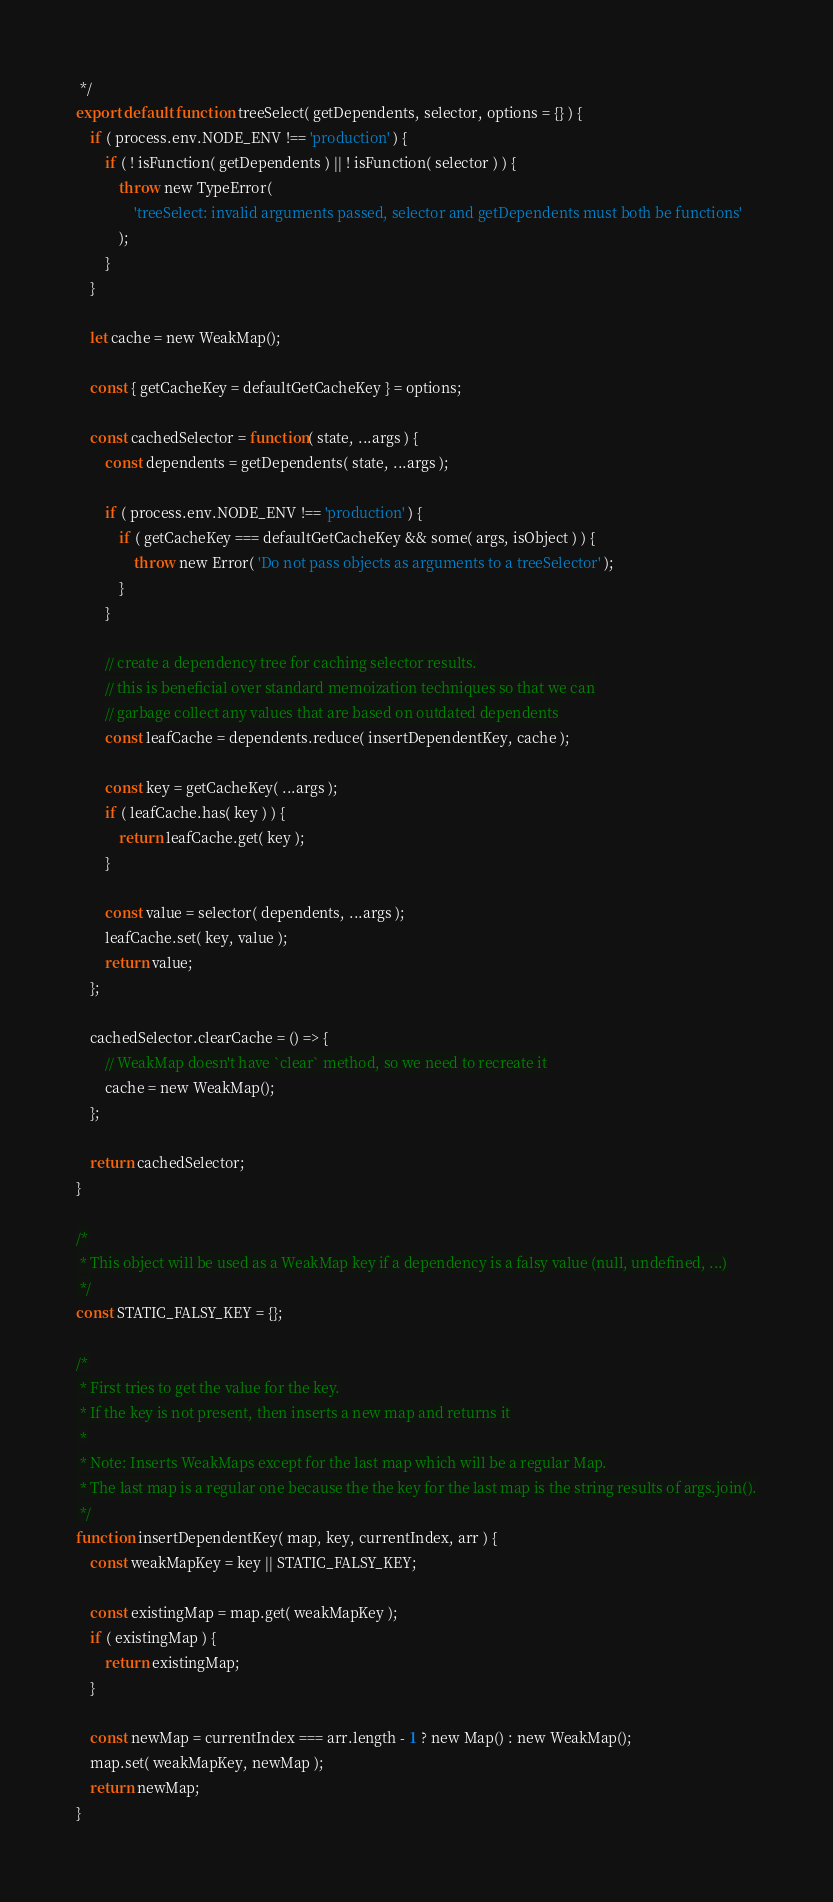<code> <loc_0><loc_0><loc_500><loc_500><_JavaScript_> */
export default function treeSelect( getDependents, selector, options = {} ) {
	if ( process.env.NODE_ENV !== 'production' ) {
		if ( ! isFunction( getDependents ) || ! isFunction( selector ) ) {
			throw new TypeError(
				'treeSelect: invalid arguments passed, selector and getDependents must both be functions'
			);
		}
	}

	let cache = new WeakMap();

	const { getCacheKey = defaultGetCacheKey } = options;

	const cachedSelector = function( state, ...args ) {
		const dependents = getDependents( state, ...args );

		if ( process.env.NODE_ENV !== 'production' ) {
			if ( getCacheKey === defaultGetCacheKey && some( args, isObject ) ) {
				throw new Error( 'Do not pass objects as arguments to a treeSelector' );
			}
		}

		// create a dependency tree for caching selector results.
		// this is beneficial over standard memoization techniques so that we can
		// garbage collect any values that are based on outdated dependents
		const leafCache = dependents.reduce( insertDependentKey, cache );

		const key = getCacheKey( ...args );
		if ( leafCache.has( key ) ) {
			return leafCache.get( key );
		}

		const value = selector( dependents, ...args );
		leafCache.set( key, value );
		return value;
	};

	cachedSelector.clearCache = () => {
		// WeakMap doesn't have `clear` method, so we need to recreate it
		cache = new WeakMap();
	};

	return cachedSelector;
}

/*
 * This object will be used as a WeakMap key if a dependency is a falsy value (null, undefined, ...)
 */
const STATIC_FALSY_KEY = {};

/*
 * First tries to get the value for the key.
 * If the key is not present, then inserts a new map and returns it
 *
 * Note: Inserts WeakMaps except for the last map which will be a regular Map.
 * The last map is a regular one because the the key for the last map is the string results of args.join().
 */
function insertDependentKey( map, key, currentIndex, arr ) {
	const weakMapKey = key || STATIC_FALSY_KEY;

	const existingMap = map.get( weakMapKey );
	if ( existingMap ) {
		return existingMap;
	}

	const newMap = currentIndex === arr.length - 1 ? new Map() : new WeakMap();
	map.set( weakMapKey, newMap );
	return newMap;
}
</code> 